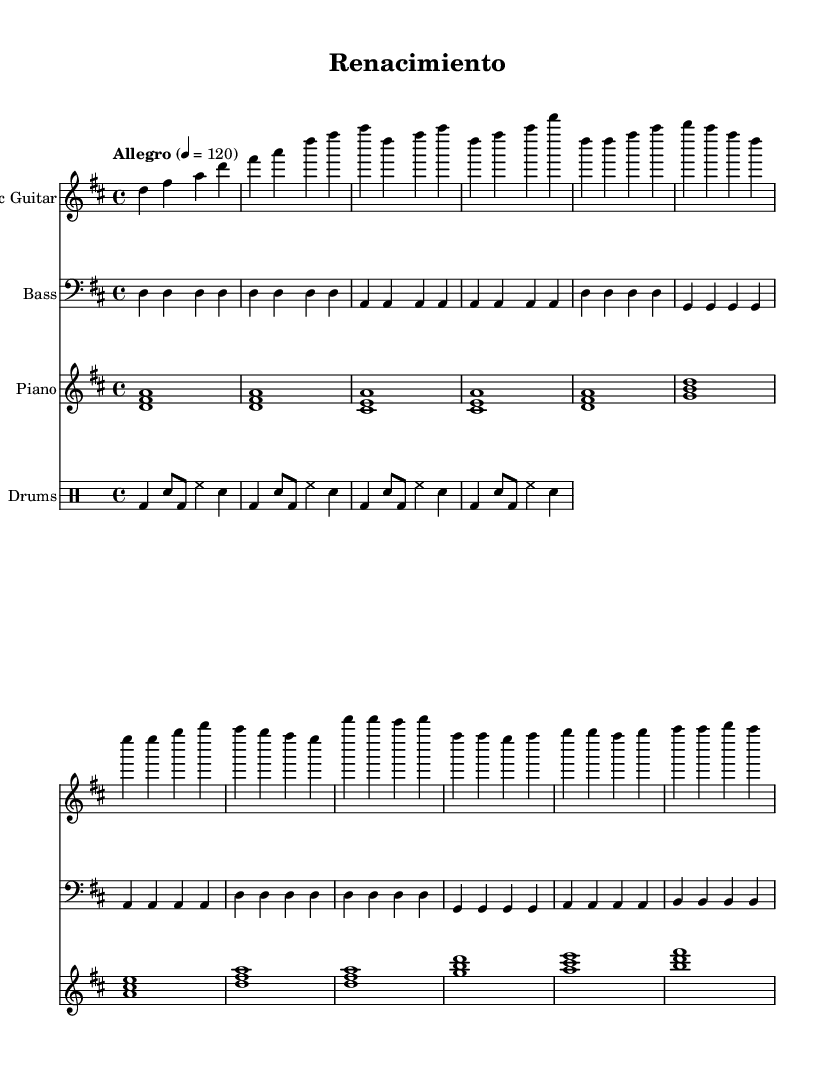What is the key signature of this music? The key signature appears at the beginning of the sheet music, where it indicates two sharps, which identify it as D major.
Answer: D major What is the time signature of the piece? The time signature is found at the beginning as well, where it is written as 4/4, indicating that there are four beats in each measure.
Answer: 4/4 What is the tempo marking for this piece? The tempo marking is specified in the tempo directive, which states "Allegro" and indicates a speed of 120 beats per minute.
Answer: Allegro, 120 How many measures are there in the introduction section? By counting the measures in the 'Intro' section for the electric guitar part, we see there are four measures.
Answer: 4 What is the relationship between the verse and the chorus sections in terms of tonality? The verse features the root note D with a consistent harmonic progression, while the chorus introduces a rise to B leading back to A, showcasing a shift from the tonic to dominant in tonality.
Answer: Tonic to dominant What rhythmic element is present in the drums part? The rhythm of the drum part is indicated at the beginning of the drumming section, which consistently shows the use of bass drums and snare hits in a basic rock beat.
Answer: Rock beat What style of music is represented here? The combination of rock elements with Latin rhythms, evident in the drum patterns and guitar stylings, typifies the fusion genre being represented here.
Answer: Latin-rock fusion 